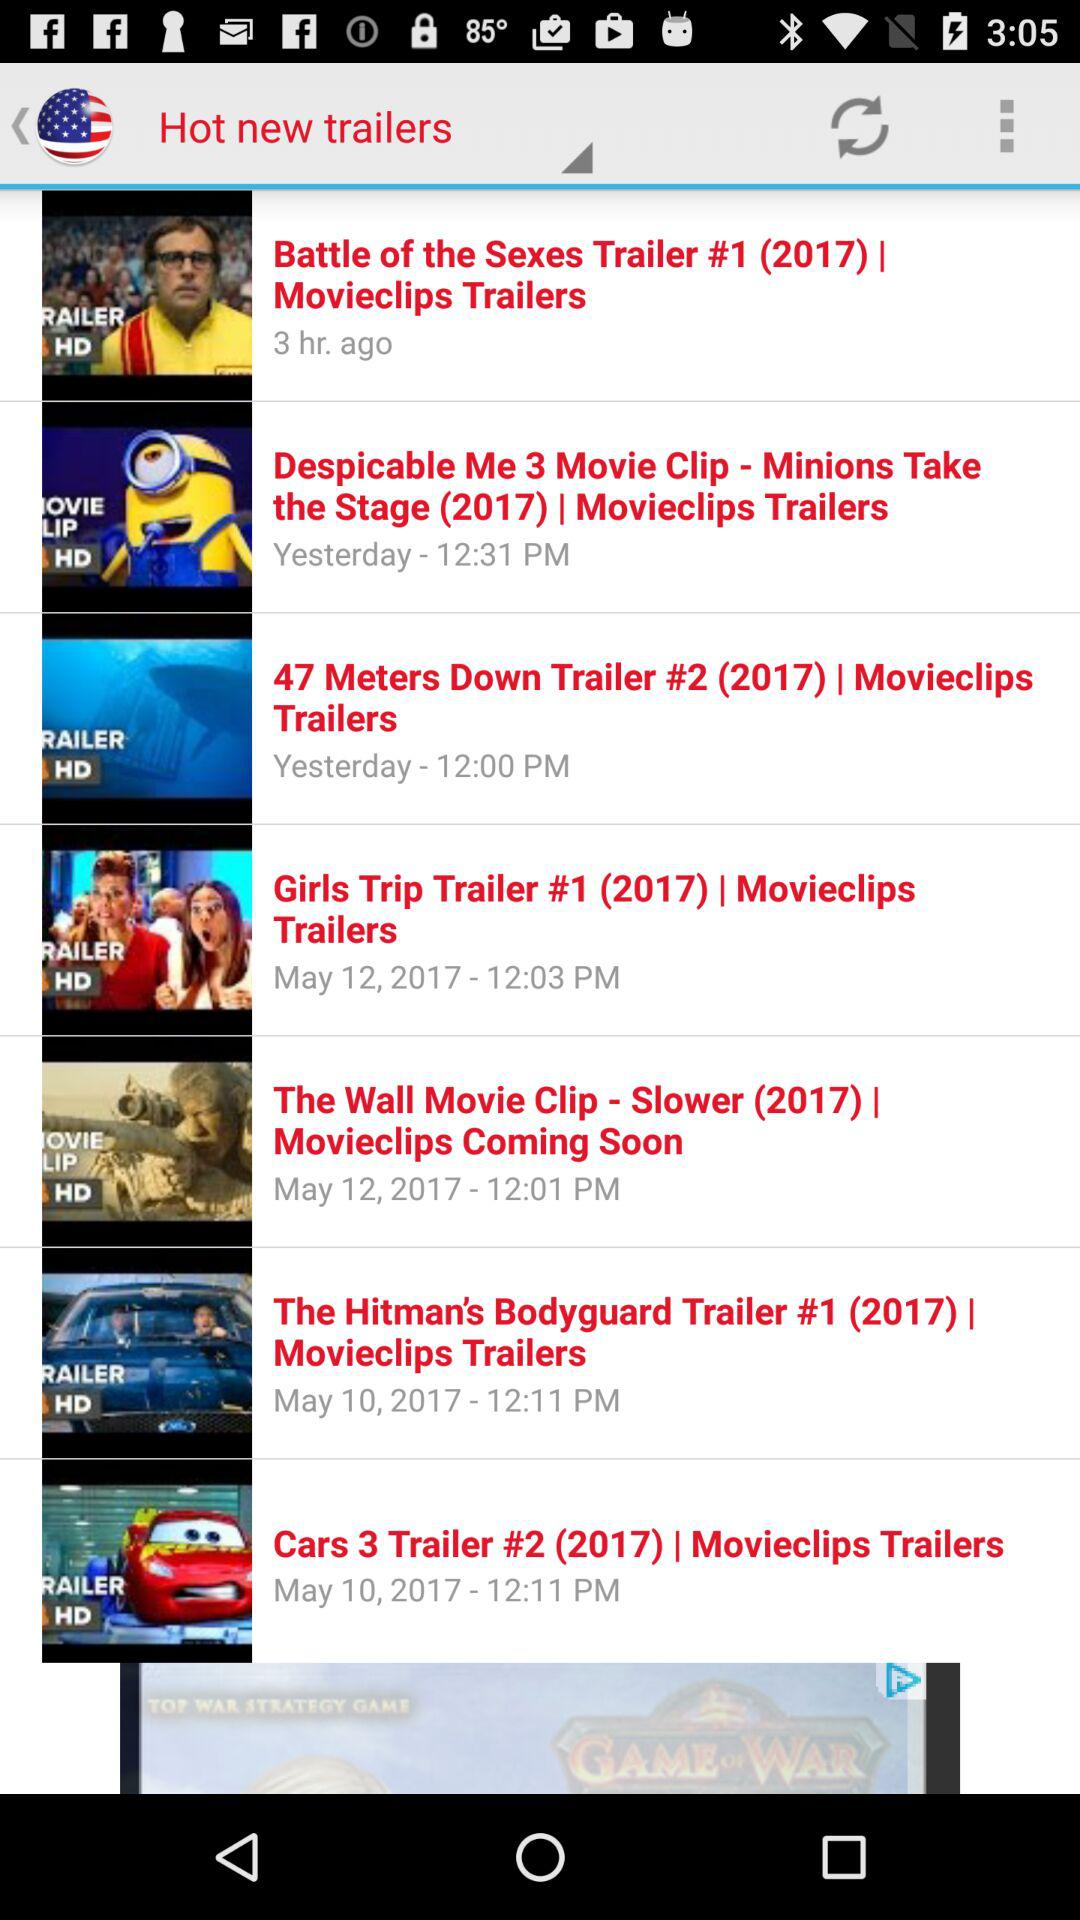When and at what time was the "Cars 3 Trailer #2" uploaded? The "Cars 3 Trailer #2" was uploaded on May 10, 2017 at 12:11 PM. 